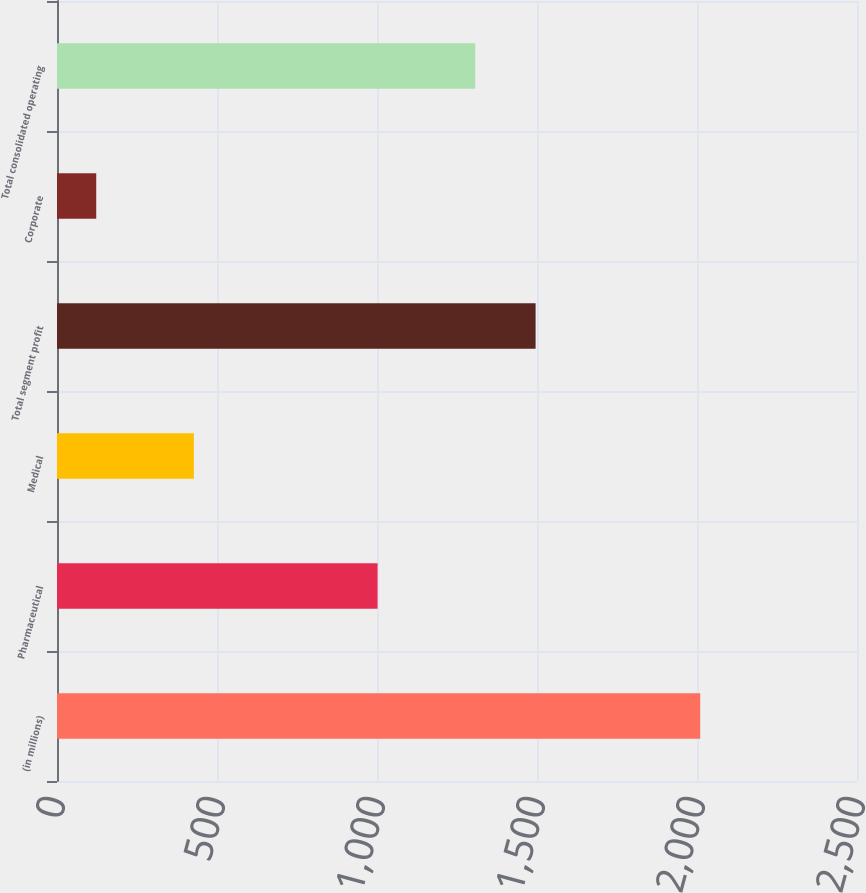<chart> <loc_0><loc_0><loc_500><loc_500><bar_chart><fcel>(in millions)<fcel>Pharmaceutical<fcel>Medical<fcel>Total segment profit<fcel>Corporate<fcel>Total consolidated operating<nl><fcel>2010<fcel>1001.8<fcel>427.7<fcel>1495.64<fcel>122.6<fcel>1306.9<nl></chart> 